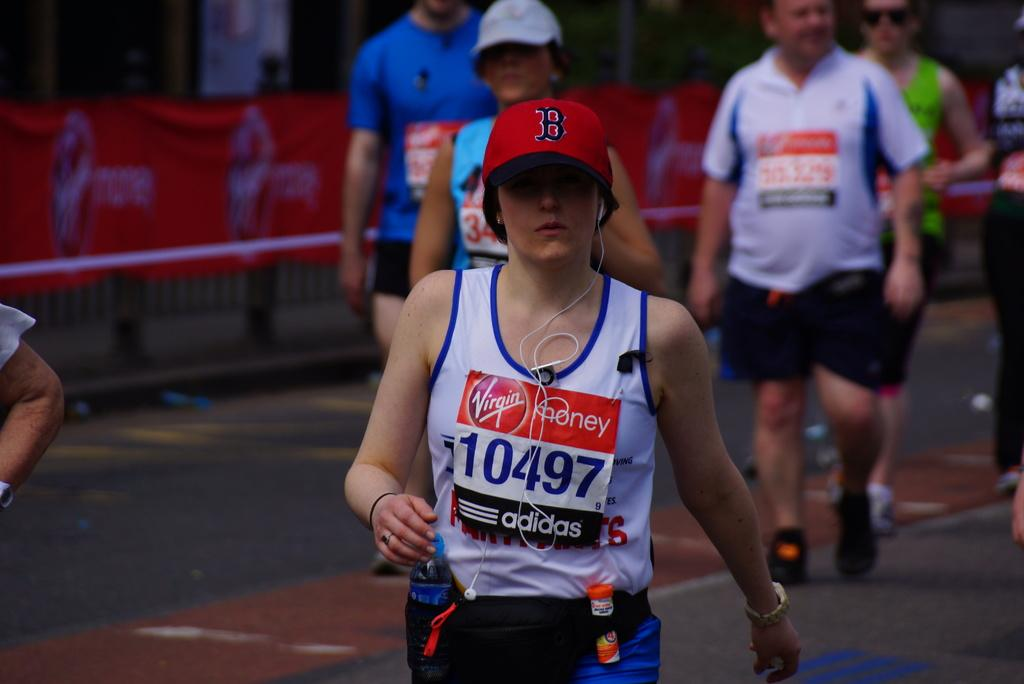<image>
Give a short and clear explanation of the subsequent image. Adidas and Virgin Money are sponsoring a runner wearing a Boston hat. 